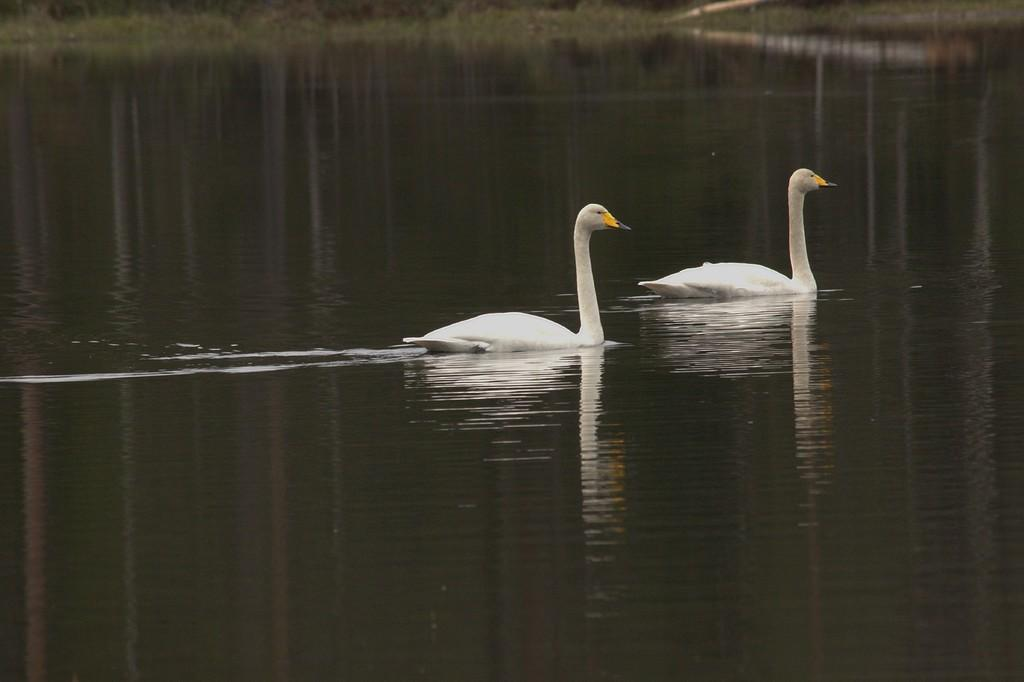What animals are present in the image? There are two white swans in the image. Where are the swans located? The swans are on the water. Can you describe the quality of the image? The image is slightly blurry in the background. What type of fang can be seen in the image? There are no fangs present in the image; it features two white swans on the water. 